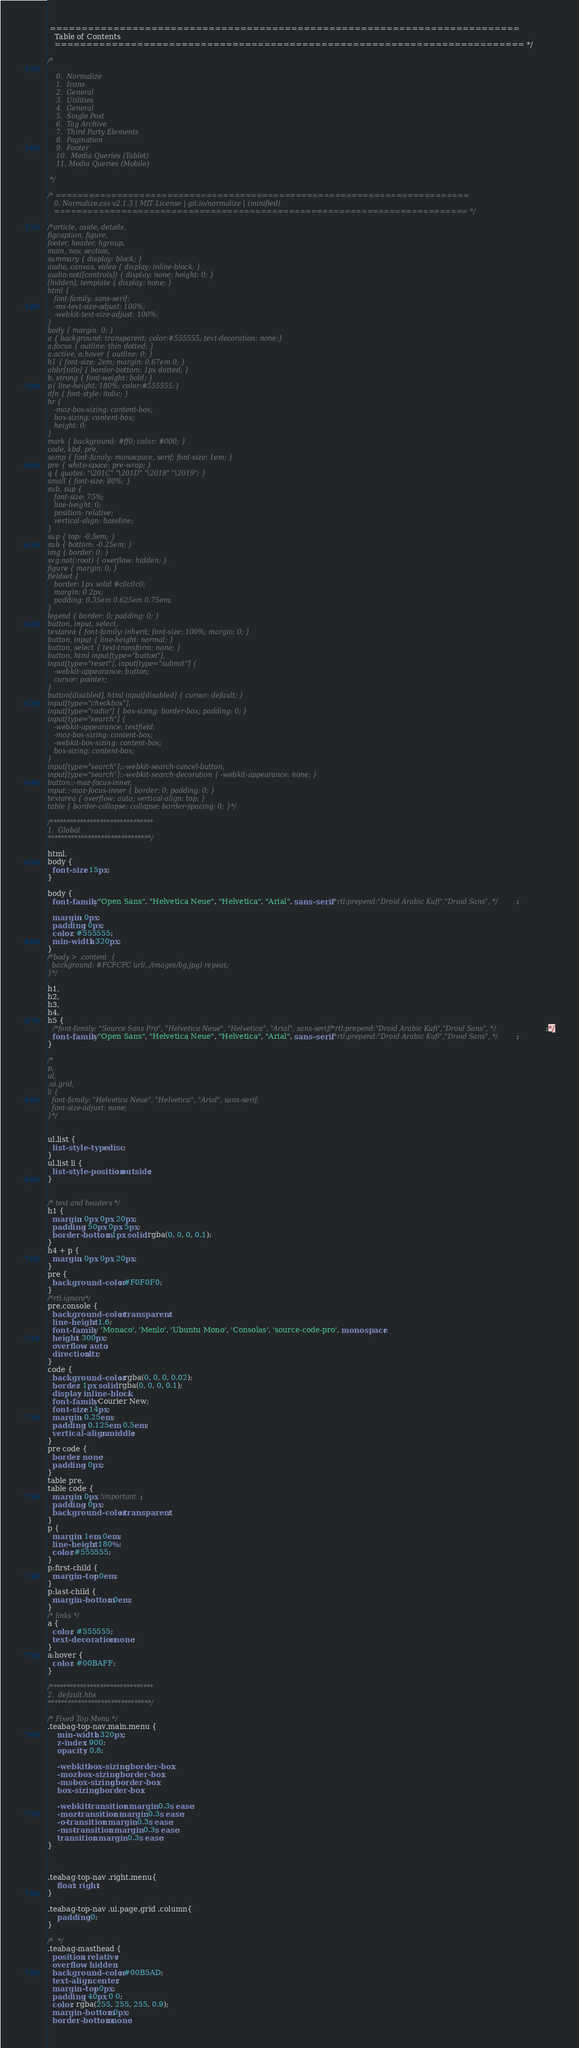Convert code to text. <code><loc_0><loc_0><loc_500><loc_500><_CSS_> ==========================================================================
   Table of Contents
   ========================================================================== */

/*

    0.  Normalize
    1.  Icons
    2.  General
    3.  Utilities
    4.  General
    5.  Single Post
    6.  Tag Archive
    7.  Third Party Elements
    8.  Pagination
    9.  Footer
    10.  Media Queries (Tablet)
    11. Media Queries (Mobile)

 */

/* ==========================================================================
   0. Normalize.css v2.1.3 | MIT License | git.io/normalize | (minified)
   ========================================================================== */

/*article, aside, details,
figcaption, figure,
footer, header, hgroup,
main, nav, section,
summary { display: block; }
audio, canvas, video { display: inline-block; }
audio:not([controls]) { display: none; height: 0; }
[hidden], template { display: none; }
html {
   font-family: sans-serif;
   -ms-text-size-adjust: 100%;
   -webkit-text-size-adjust: 100%;
}
body { margin: 0; }
a { background: transparent; color:#555555; text-decoration: none;}
a:focus { outline: thin dotted; }
a:active, a:hover { outline: 0; }
h1 { font-size: 2em; margin: 0.67em 0; }
abbr[title] { border-bottom: 1px dotted; }
b, strong { font-weight: bold; }
p{ line-height: 180%; color:#555555;}
dfn { font-style: italic; }
hr {
   -moz-box-sizing: content-box;
   box-sizing: content-box;
   height: 0;
}
mark { background: #ff0; color: #000; }
code, kbd, pre,
samp { font-family: monospace, serif; font-size: 1em; }
pre { white-space: pre-wrap; }
q { quotes: "\201C" "\201D" "\2018" "\2019"; }
small { font-size: 80%; }
sub, sup {
   font-size: 75%;
   line-height: 0;
   position: relative;
   vertical-align: baseline;
}
sup { top: -0.5em; }
sub { bottom: -0.25em; }
img { border: 0; }
svg:not(:root) { overflow: hidden; }
figure { margin: 0; }
fieldset {
   border: 1px solid #c0c0c0;
   margin: 0 2px;
   padding: 0.35em 0.625em 0.75em;
}
legend { border: 0; padding: 0; }
button, input, select,
textarea { font-family: inherit; font-size: 100%; margin: 0; }
button, input { line-height: normal; }
button, select { text-transform: none; }
button, html input[type="button"],
input[type="reset"], input[type="submit"] {
   -webkit-appearance: button;
   cursor: pointer;
}
button[disabled], html input[disabled] { cursor: default; }
input[type="checkbox"],
input[type="radio"] { box-sizing: border-box; padding: 0; }
input[type="search"] {
   -webkit-appearance: textfield;
   -moz-box-sizing: content-box;
   -webkit-box-sizing: content-box;
   box-sizing: content-box;
}
input[type="search"]::-webkit-search-cancel-button,
input[type="search"]::-webkit-search-decoration { -webkit-appearance: none; }
button::-moz-focus-inner,
input::-moz-focus-inner { border: 0; padding: 0; }
textarea { overflow: auto; vertical-align: top; }
table { border-collapse: collapse; border-spacing: 0; }*/

/*******************************
1.  Global
*******************************/

html,
body {
  font-size: 15px;
}

body {
  font-family: "Open Sans", "Helvetica Neue", "Helvetica", "Arial", sans-serif/*rtl:prepend:"Droid Arabic Kufi","Droid Sans", */;

  margin: 0px;
  padding: 0px;
  color: #555555;
  min-width: 320px;
}
/*body > .content  {
  background: #FCFCFC url(../images/bg.jpg) repeat;
}*/

h1,
h2,
h3,
h4,
h5 {
  /*font-family: "Source Sans Pro", "Helvetica Neue", "Helvetica", "Arial", sans-serif/*rtl:prepend:"Droid Arabic Kufi","Droid Sans", */;*/
  font-family: "Open Sans", "Helvetica Neue", "Helvetica", "Arial", sans-serif/*rtl:prepend:"Droid Arabic Kufi","Droid Sans", */;
}

/*
p,
ul,
.ui.grid,
li {
  font-family: "Helvetica Neue", "Helvetica", "Arial", sans-serif;
  font-size-adjust: none;
}*/


ul.list {
  list-style-type: disc;
}
ul.list li {
  list-style-position: outside;
}


/* text and headers */
h1 {
  margin: 0px 0px 20px;
  padding: 50px 0px 5px;
  border-bottom: 1px solid rgba(0, 0, 0, 0.1);
}
h4 + p {
  margin: 0px 0px 20px;
}
pre {
  background-color: #F0F0F0;
}
/*rtl:ignore*/
pre.console {
  background-color: transparent;
  line-height: 1.6;
  font-family:  'Monaco', 'Menlo', 'Ubuntu Mono', 'Consolas', 'source-code-pro', monospace;
  height: 300px;
  overflow: auto;
  direction:ltr;
}
code {
  background-color: rgba(0, 0, 0, 0.02);
  border: 1px solid rgba(0, 0, 0, 0.1);
  display: inline-block;
  font-family: Courier New;
  font-size: 14px;
  margin: 0.25em;
  padding: 0.125em 0.5em;
  vertical-align: middle;
}
pre code {
  border: none;
  padding: 0px;
}
table pre,
table code {
  margin: 0px !important;
  padding: 0px;
  background-color: transparent;
}
p {
  margin: 1em 0em;
  line-height: 180%; 
  color:#555555;
}
p:first-child {
  margin-top: 0em;
}
p:last-child {
  margin-bottom: 0em;
}
/* links */
a {
  color: #555555;
  text-decoration: none;
}
a:hover {
  color: #00BAFF;
}

/*******************************
2.  default.hbs
*******************************/

/* Fixed Top Menu */
.teabag-top-nav.main.menu {
	min-width: 320px;
	z-index: 900;
	opacity: 0.8;

	-webkit-box-sizing: border-box;
	-moz-box-sizing: border-box;
	-ms-box-sizing: border-box;
	box-sizing: border-box;

	-webkit-transition: margin 0.3s ease;
	-moz-transition: margin 0.3s ease;
	-o-transition: margin 0.3s ease;
	-ms-transition: margin 0.3s ease;
	transition: margin 0.3s ease;
}



.teabag-top-nav .right.menu{
	float: right;
}

.teabag-top-nav .ui.page.grid .column{
	padding:0;
}

/*  */
.teabag-masthead {
  position: relative;
  overflow: hidden;
  background-color: #00B5AD;
  text-align: center;
  margin-top: 0px;
  padding: 40px 0 0;
  color: rgba(255, 255, 255, 0.9);
  margin-bottom: 0px;
  border-bottom: none;</code> 